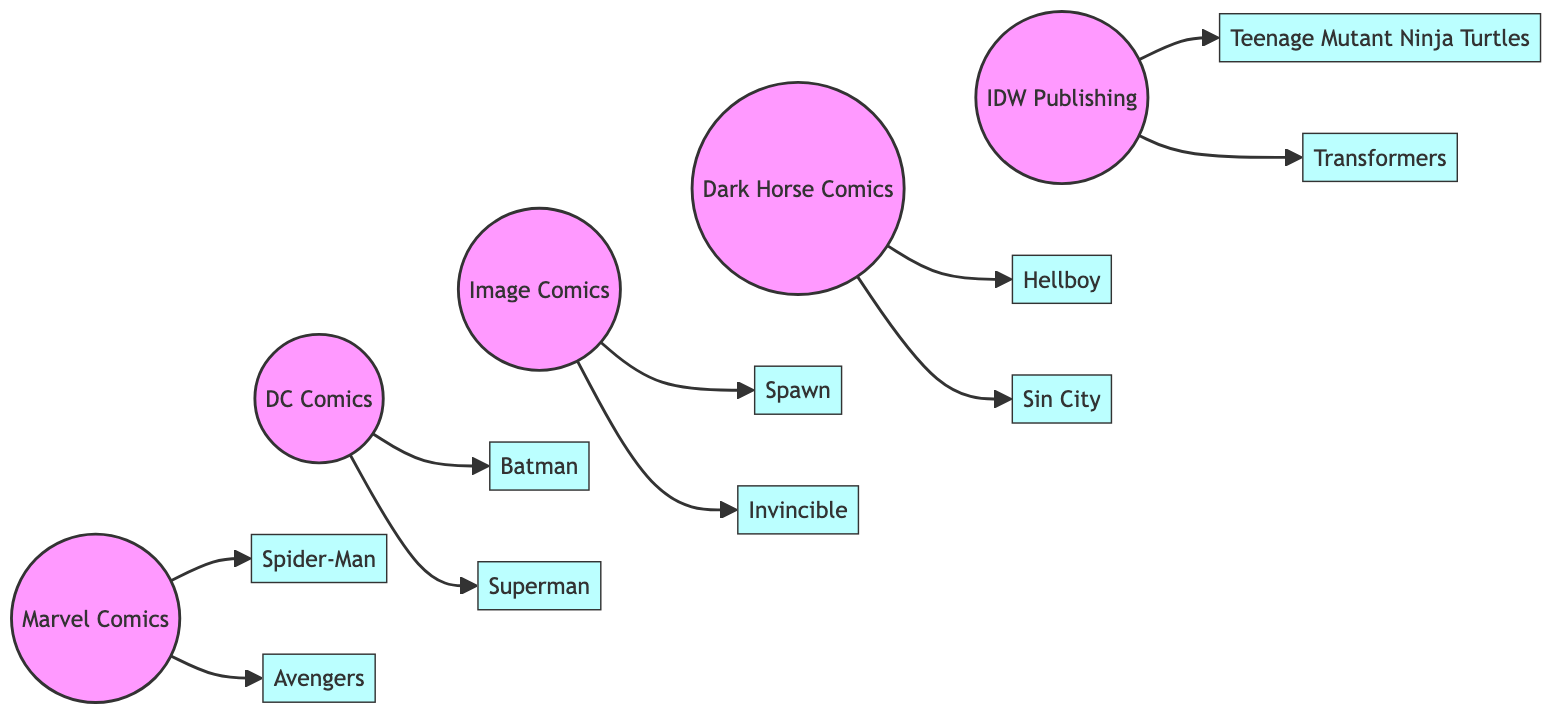What is the total number of comic book publishers in the diagram? To find the total number of comic book publishers, we can count the unique publisher nodes listed. The nodes are Marvel, DC, Image, Dark Horse, and IDW, which equal five distinct publishers.
Answer: 5 How many comic titles are published by Marvel? By analyzing the edges connected to the Marvel node, we see two comic titles linked: Spider-Man and Avengers. This gives us a total of two comic titles published by Marvel.
Answer: 2 Which publisher is associated with the comic title "Teenage Mutant Ninja Turtles"? Looking at the edges, the IDW node connects to the TMNT node. This indicates that the publisher associated with "Teenage Mutant Ninja Turtles" is IDW.
Answer: IDW Is "Batman" published by Marvel? To determine this, we check the edges connected to the Batman node. Since Batman is connected to the DC node and not Marvel, it confirms Batman is not published by Marvel.
Answer: No What are the names of the two comic titles published by Image Comics? We examine the edges from the Image node and find that two comic titles, Spawn and Invincible, are connected to it, indicating that these are the titles published by Image.
Answer: Spawn, Invincible Which publisher has the most comic titles listed in the diagram? We can track the edges connected to each publisher. Marvel has 2 titles, DC has 2 titles, Image has 2 titles, Dark Horse has 2 titles, and IDW has 2 titles. Since all publishers listed have an equal number, there is no single publisher with the most titles.
Answer: None How many comic titles does Dark Horse Comics publish? By inspecting the edges connected to the Dark Horse node, we see that it is linked to two titles: Hellboy and Sin City. Thus, Dark Horse Comics publishes a total of two comic titles.
Answer: 2 Which comic title is unique to IDW Publishing? From the analysis of the edges, we see that both TMNT and Transformers are connected to IDW. However, only TMNT is often considered a distinctive title associated with IDW. Therefore, TMNT is recognized as a unique comic title for IDW.
Answer: Teenage Mutant Ninja Turtles 